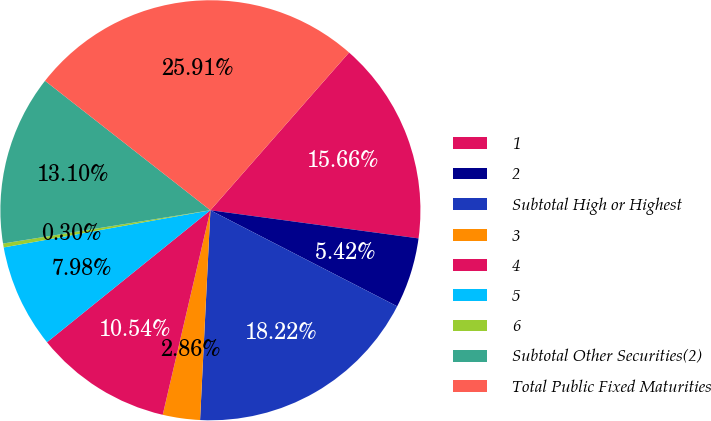<chart> <loc_0><loc_0><loc_500><loc_500><pie_chart><fcel>1<fcel>2<fcel>Subtotal High or Highest<fcel>3<fcel>4<fcel>5<fcel>6<fcel>Subtotal Other Securities(2)<fcel>Total Public Fixed Maturities<nl><fcel>15.66%<fcel>5.42%<fcel>18.22%<fcel>2.86%<fcel>10.54%<fcel>7.98%<fcel>0.3%<fcel>13.1%<fcel>25.9%<nl></chart> 